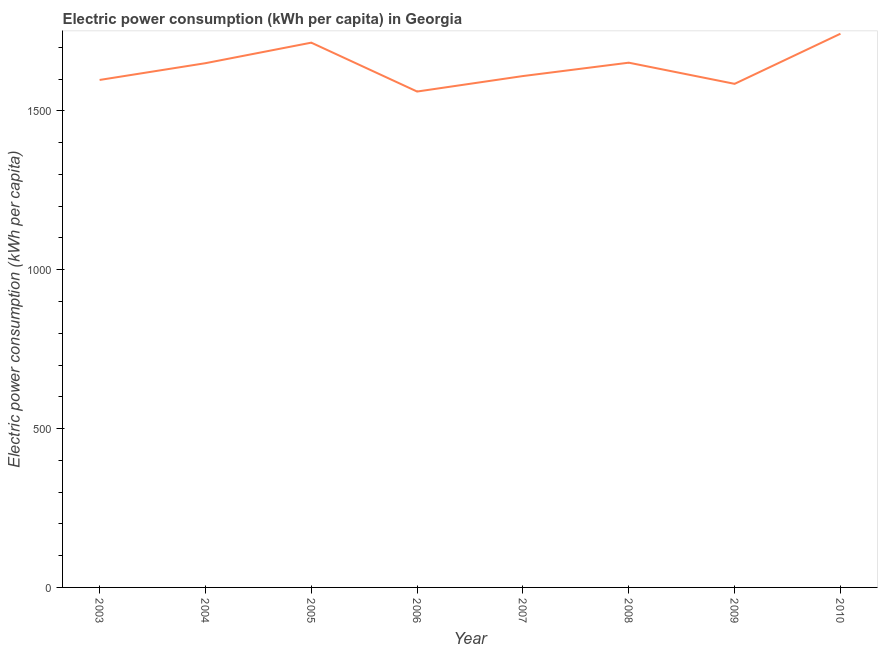What is the electric power consumption in 2005?
Give a very brief answer. 1714.82. Across all years, what is the maximum electric power consumption?
Make the answer very short. 1742.95. Across all years, what is the minimum electric power consumption?
Your response must be concise. 1560.94. In which year was the electric power consumption maximum?
Give a very brief answer. 2010. What is the sum of the electric power consumption?
Your answer should be very brief. 1.31e+04. What is the difference between the electric power consumption in 2003 and 2006?
Provide a short and direct response. 36.47. What is the average electric power consumption per year?
Your answer should be very brief. 1639.11. What is the median electric power consumption?
Ensure brevity in your answer.  1629.94. What is the ratio of the electric power consumption in 2006 to that in 2010?
Make the answer very short. 0.9. What is the difference between the highest and the second highest electric power consumption?
Your answer should be compact. 28.13. What is the difference between the highest and the lowest electric power consumption?
Provide a short and direct response. 182.01. In how many years, is the electric power consumption greater than the average electric power consumption taken over all years?
Keep it short and to the point. 4. Does the electric power consumption monotonically increase over the years?
Keep it short and to the point. No. How many lines are there?
Give a very brief answer. 1. How many years are there in the graph?
Your response must be concise. 8. Are the values on the major ticks of Y-axis written in scientific E-notation?
Make the answer very short. No. Does the graph contain any zero values?
Give a very brief answer. No. Does the graph contain grids?
Make the answer very short. No. What is the title of the graph?
Your response must be concise. Electric power consumption (kWh per capita) in Georgia. What is the label or title of the X-axis?
Ensure brevity in your answer.  Year. What is the label or title of the Y-axis?
Offer a terse response. Electric power consumption (kWh per capita). What is the Electric power consumption (kWh per capita) in 2003?
Your answer should be very brief. 1597.4. What is the Electric power consumption (kWh per capita) of 2004?
Your answer should be very brief. 1650.19. What is the Electric power consumption (kWh per capita) of 2005?
Give a very brief answer. 1714.82. What is the Electric power consumption (kWh per capita) in 2006?
Your answer should be very brief. 1560.94. What is the Electric power consumption (kWh per capita) in 2007?
Offer a terse response. 1609.7. What is the Electric power consumption (kWh per capita) of 2008?
Keep it short and to the point. 1651.76. What is the Electric power consumption (kWh per capita) of 2009?
Make the answer very short. 1585.16. What is the Electric power consumption (kWh per capita) in 2010?
Your answer should be very brief. 1742.95. What is the difference between the Electric power consumption (kWh per capita) in 2003 and 2004?
Provide a succinct answer. -52.78. What is the difference between the Electric power consumption (kWh per capita) in 2003 and 2005?
Keep it short and to the point. -117.41. What is the difference between the Electric power consumption (kWh per capita) in 2003 and 2006?
Give a very brief answer. 36.47. What is the difference between the Electric power consumption (kWh per capita) in 2003 and 2007?
Ensure brevity in your answer.  -12.29. What is the difference between the Electric power consumption (kWh per capita) in 2003 and 2008?
Offer a terse response. -54.36. What is the difference between the Electric power consumption (kWh per capita) in 2003 and 2009?
Ensure brevity in your answer.  12.24. What is the difference between the Electric power consumption (kWh per capita) in 2003 and 2010?
Offer a terse response. -145.54. What is the difference between the Electric power consumption (kWh per capita) in 2004 and 2005?
Provide a short and direct response. -64.63. What is the difference between the Electric power consumption (kWh per capita) in 2004 and 2006?
Make the answer very short. 89.25. What is the difference between the Electric power consumption (kWh per capita) in 2004 and 2007?
Provide a succinct answer. 40.49. What is the difference between the Electric power consumption (kWh per capita) in 2004 and 2008?
Provide a succinct answer. -1.58. What is the difference between the Electric power consumption (kWh per capita) in 2004 and 2009?
Provide a succinct answer. 65.02. What is the difference between the Electric power consumption (kWh per capita) in 2004 and 2010?
Offer a terse response. -92.76. What is the difference between the Electric power consumption (kWh per capita) in 2005 and 2006?
Offer a very short reply. 153.88. What is the difference between the Electric power consumption (kWh per capita) in 2005 and 2007?
Provide a short and direct response. 105.12. What is the difference between the Electric power consumption (kWh per capita) in 2005 and 2008?
Your answer should be compact. 63.05. What is the difference between the Electric power consumption (kWh per capita) in 2005 and 2009?
Offer a terse response. 129.65. What is the difference between the Electric power consumption (kWh per capita) in 2005 and 2010?
Your response must be concise. -28.13. What is the difference between the Electric power consumption (kWh per capita) in 2006 and 2007?
Give a very brief answer. -48.76. What is the difference between the Electric power consumption (kWh per capita) in 2006 and 2008?
Offer a very short reply. -90.83. What is the difference between the Electric power consumption (kWh per capita) in 2006 and 2009?
Your response must be concise. -24.23. What is the difference between the Electric power consumption (kWh per capita) in 2006 and 2010?
Keep it short and to the point. -182.01. What is the difference between the Electric power consumption (kWh per capita) in 2007 and 2008?
Offer a very short reply. -42.07. What is the difference between the Electric power consumption (kWh per capita) in 2007 and 2009?
Keep it short and to the point. 24.53. What is the difference between the Electric power consumption (kWh per capita) in 2007 and 2010?
Ensure brevity in your answer.  -133.25. What is the difference between the Electric power consumption (kWh per capita) in 2008 and 2009?
Ensure brevity in your answer.  66.6. What is the difference between the Electric power consumption (kWh per capita) in 2008 and 2010?
Keep it short and to the point. -91.18. What is the difference between the Electric power consumption (kWh per capita) in 2009 and 2010?
Give a very brief answer. -157.78. What is the ratio of the Electric power consumption (kWh per capita) in 2003 to that in 2004?
Make the answer very short. 0.97. What is the ratio of the Electric power consumption (kWh per capita) in 2003 to that in 2005?
Your answer should be very brief. 0.93. What is the ratio of the Electric power consumption (kWh per capita) in 2003 to that in 2008?
Your answer should be compact. 0.97. What is the ratio of the Electric power consumption (kWh per capita) in 2003 to that in 2010?
Give a very brief answer. 0.92. What is the ratio of the Electric power consumption (kWh per capita) in 2004 to that in 2006?
Your response must be concise. 1.06. What is the ratio of the Electric power consumption (kWh per capita) in 2004 to that in 2007?
Provide a succinct answer. 1.02. What is the ratio of the Electric power consumption (kWh per capita) in 2004 to that in 2009?
Provide a succinct answer. 1.04. What is the ratio of the Electric power consumption (kWh per capita) in 2004 to that in 2010?
Provide a succinct answer. 0.95. What is the ratio of the Electric power consumption (kWh per capita) in 2005 to that in 2006?
Keep it short and to the point. 1.1. What is the ratio of the Electric power consumption (kWh per capita) in 2005 to that in 2007?
Ensure brevity in your answer.  1.06. What is the ratio of the Electric power consumption (kWh per capita) in 2005 to that in 2008?
Offer a very short reply. 1.04. What is the ratio of the Electric power consumption (kWh per capita) in 2005 to that in 2009?
Offer a terse response. 1.08. What is the ratio of the Electric power consumption (kWh per capita) in 2006 to that in 2007?
Make the answer very short. 0.97. What is the ratio of the Electric power consumption (kWh per capita) in 2006 to that in 2008?
Provide a short and direct response. 0.94. What is the ratio of the Electric power consumption (kWh per capita) in 2006 to that in 2010?
Make the answer very short. 0.9. What is the ratio of the Electric power consumption (kWh per capita) in 2007 to that in 2008?
Make the answer very short. 0.97. What is the ratio of the Electric power consumption (kWh per capita) in 2007 to that in 2010?
Provide a succinct answer. 0.92. What is the ratio of the Electric power consumption (kWh per capita) in 2008 to that in 2009?
Your answer should be compact. 1.04. What is the ratio of the Electric power consumption (kWh per capita) in 2008 to that in 2010?
Your response must be concise. 0.95. What is the ratio of the Electric power consumption (kWh per capita) in 2009 to that in 2010?
Offer a terse response. 0.91. 